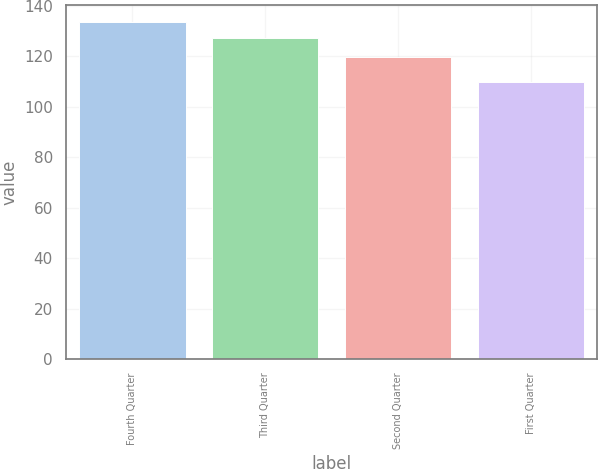Convert chart. <chart><loc_0><loc_0><loc_500><loc_500><bar_chart><fcel>Fourth Quarter<fcel>Third Quarter<fcel>Second Quarter<fcel>First Quarter<nl><fcel>133.47<fcel>127.31<fcel>119.82<fcel>109.67<nl></chart> 